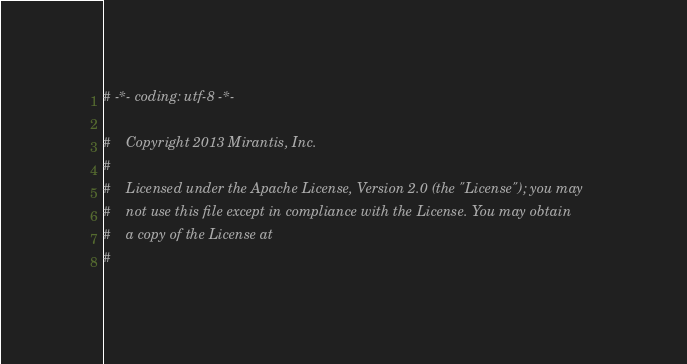<code> <loc_0><loc_0><loc_500><loc_500><_Python_># -*- coding: utf-8 -*-

#    Copyright 2013 Mirantis, Inc.
#
#    Licensed under the Apache License, Version 2.0 (the "License"); you may
#    not use this file except in compliance with the License. You may obtain
#    a copy of the License at
#</code> 